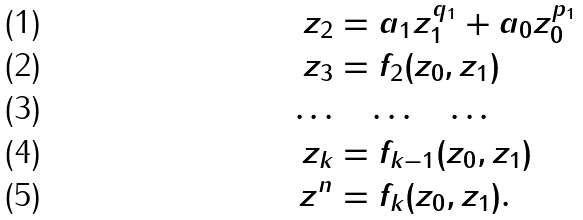<formula> <loc_0><loc_0><loc_500><loc_500>z _ { 2 } & = a _ { 1 } z _ { 1 } ^ { q _ { 1 } } + a _ { 0 } z _ { 0 } ^ { p _ { 1 } } \\ z _ { 3 } & = f _ { 2 } ( z _ { 0 } , z _ { 1 } ) \\ \dots & \quad \dots \quad \dots \\ z _ { k } & = f _ { k - 1 } ( z _ { 0 } , z _ { 1 } ) \\ z ^ { n } & = f _ { k } ( z _ { 0 } , z _ { 1 } ) .</formula> 